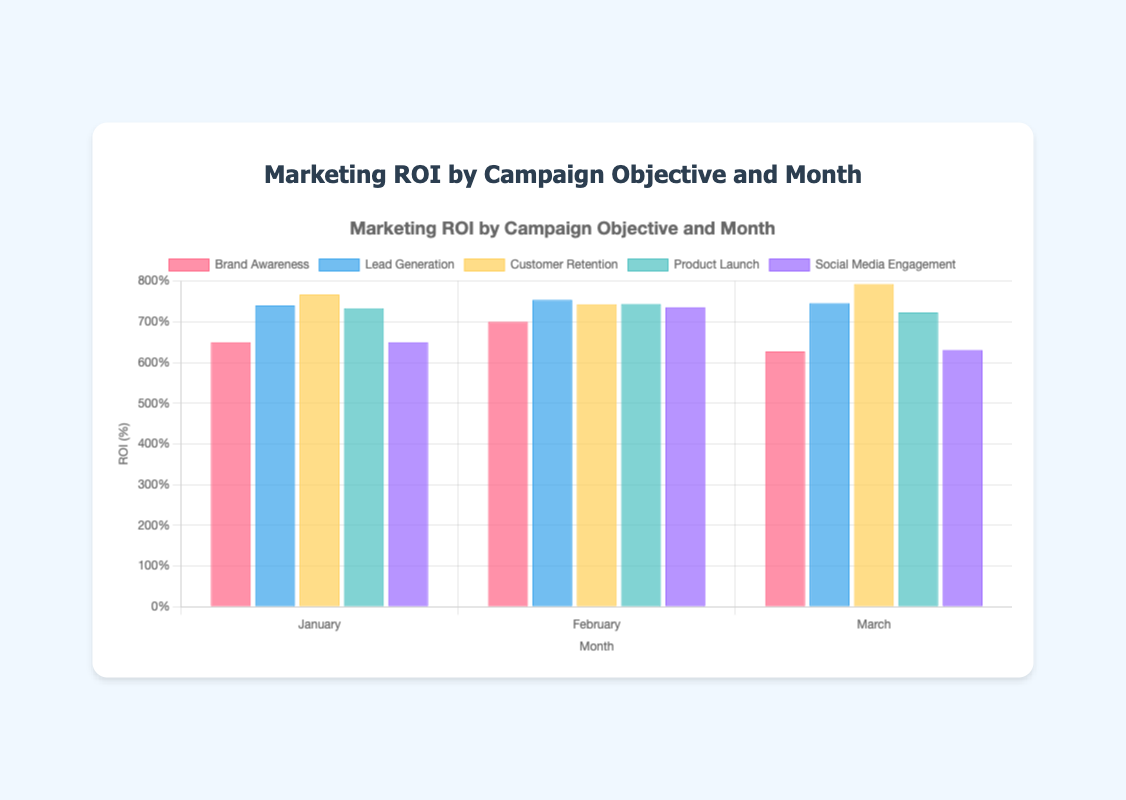Which campaign had the highest ROI in January? In January, the Campaigns are "Brand Awareness", "Lead Generation", "Customer Retention", "Product Launch", and "Social Media Engagement". Look at each bar's height in the January cluster to determine the highest one. "Customer Retention" had the highest ROI at 767.
Answer: Customer Retention Which month saw the lowest ROI for Social Media Engagement? For "Social Media Engagement", compare the heights of the bars for January, February, and March. The bar for March is the shortest among the three, indicating the lowest ROI.
Answer: March What is the difference in ROI between Lead Generation in February and March? Identify the heights of the bars for "Lead Generation" in February and March. February has an ROI of 754, and March has an ROI of 746. Calculate the difference: 754 - 746 = 8.
Answer: 8 What is the average ROI for Brand Awareness over the three months? Calculate the average by summing the ROIs for "Brand Awareness" in January, February, and March and dividing by 3. ROIs are 650, 700, and 627. Sum = 650 + 700 + 627 = 1977. Average = 1977 / 3 = 659.
Answer: 659 Which campaign shows the most consistent ROI across all months? For each campaign, observe the variation of the bars across January, February, and March. "Lead Generation" has ROIs of 740, 754, and 746, which are relatively close to each other, indicating consistency.
Answer: Lead Generation Between which two months did Brand Awareness have the largest increase in ROI? Look at the height of the "Brand Awareness" bars for each month. January to February increased from 650 to 700 (50). February to March decreased from 700 to 627 (-73). The largest increase is between January and February.
Answer: January to February What is the combined ROI of Customer Retention and Product Launch in March? Determine the ROI for each campaign in March: "Customer Retention" is 793 and "Product Launch" is 723. Sum these values: 793 + 723 = 1516.
Answer: 1516 Which campaign had a declining ROI from January to March? For each campaign, check the heights of the bars from January to March. "Brand Awareness" (650, 700, 627) shows a decline from February to March. "Social Media Engagement" (650, 736, 631) shows a decline from February to March.
Answer: Brand Awareness, Social Media Engagement Which campaign had the highest ROI in February? In February, the campaigns are all visible with different bar heights. The highest bar is from "Lead Generation" with an ROI of 754.
Answer: Lead Generation How does the ROI of Product Launch in February compare with Customer Retention in the same month? Find the heights of the bars for "Product Launch" and "Customer Retention" in February. "Product Launch" has an ROI of 744, and "Customer Retention" has an ROI of 743. Compare these values: 744 > 743.
Answer: Product Launch is higher 